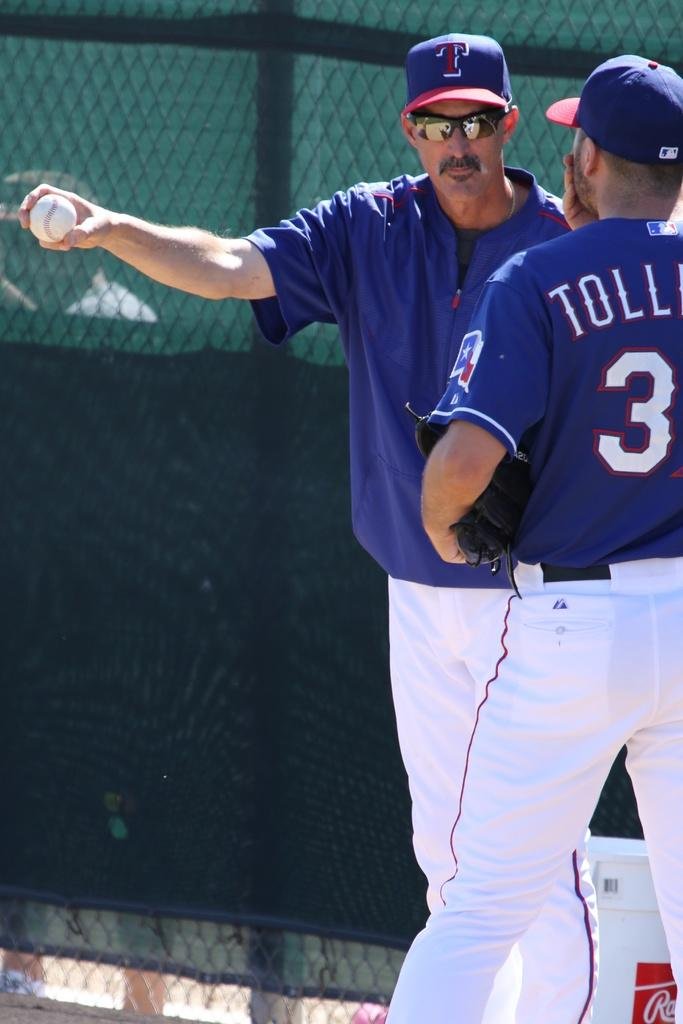<image>
Describe the image concisely. Two baseball players standing near the dugout with a "t" logo on their hat. 